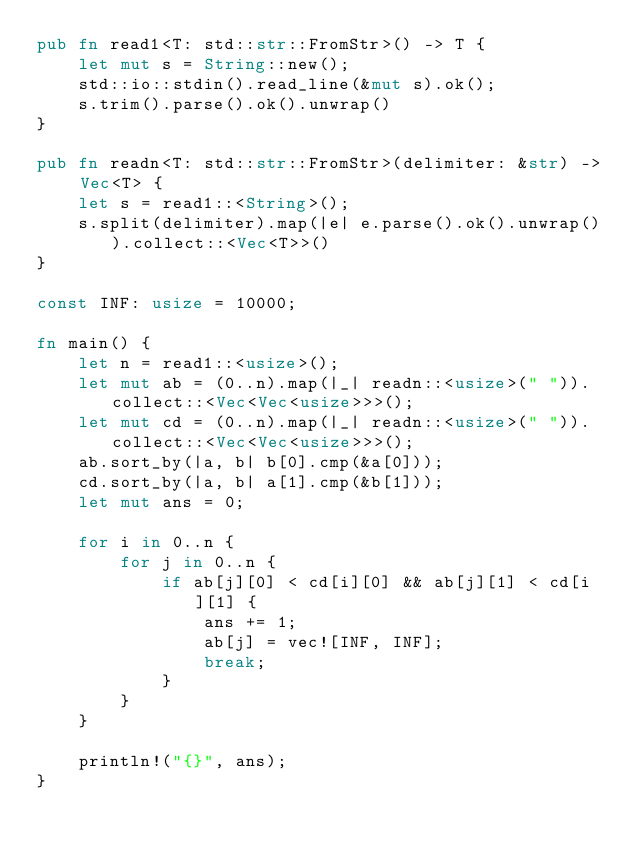Convert code to text. <code><loc_0><loc_0><loc_500><loc_500><_Rust_>pub fn read1<T: std::str::FromStr>() -> T {
    let mut s = String::new();
    std::io::stdin().read_line(&mut s).ok();
    s.trim().parse().ok().unwrap()
}

pub fn readn<T: std::str::FromStr>(delimiter: &str) -> Vec<T> {
    let s = read1::<String>();
    s.split(delimiter).map(|e| e.parse().ok().unwrap()).collect::<Vec<T>>()
}

const INF: usize = 10000;

fn main() {
    let n = read1::<usize>();
    let mut ab = (0..n).map(|_| readn::<usize>(" ")).collect::<Vec<Vec<usize>>>();
    let mut cd = (0..n).map(|_| readn::<usize>(" ")).collect::<Vec<Vec<usize>>>();
    ab.sort_by(|a, b| b[0].cmp(&a[0]));
    cd.sort_by(|a, b| a[1].cmp(&b[1]));
    let mut ans = 0;

    for i in 0..n {
        for j in 0..n {
            if ab[j][0] < cd[i][0] && ab[j][1] < cd[i][1] {
                ans += 1;
                ab[j] = vec![INF, INF];
                break;
            }
        }
    }

    println!("{}", ans);
}</code> 